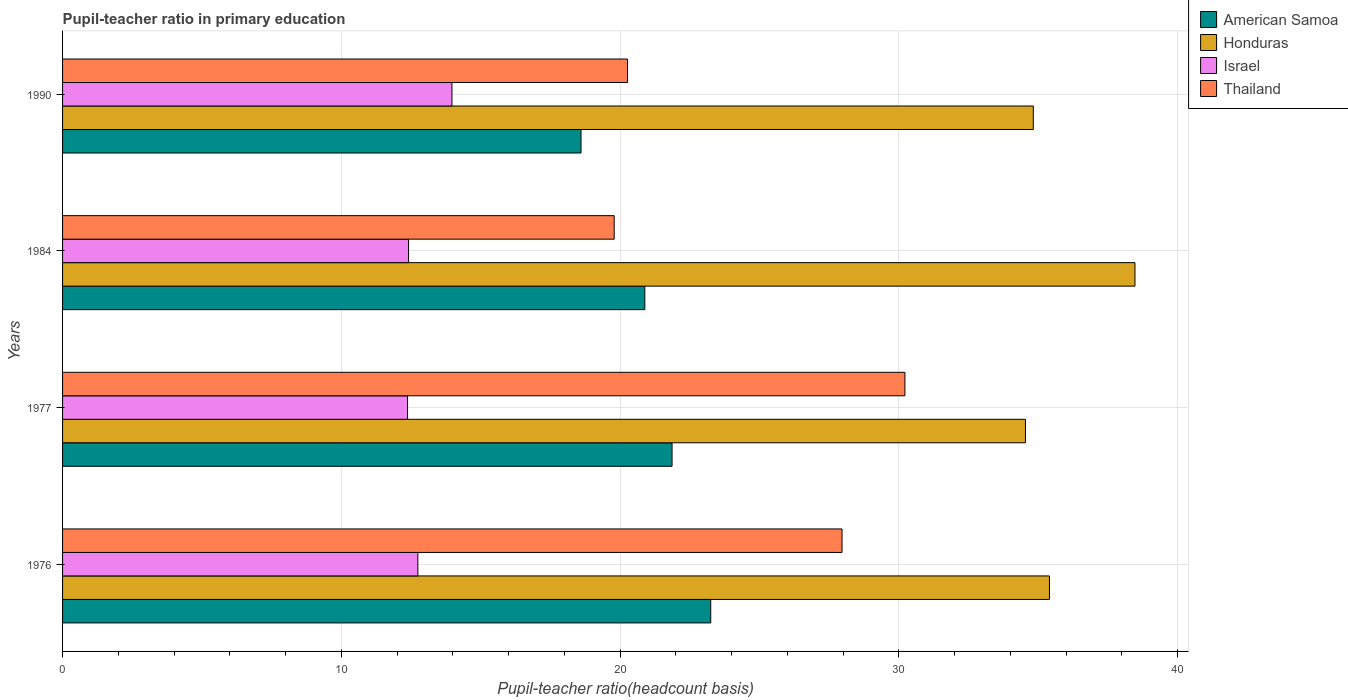How many groups of bars are there?
Make the answer very short. 4. Are the number of bars on each tick of the Y-axis equal?
Offer a terse response. Yes. How many bars are there on the 4th tick from the top?
Offer a very short reply. 4. What is the pupil-teacher ratio in primary education in Honduras in 1977?
Offer a terse response. 34.54. Across all years, what is the maximum pupil-teacher ratio in primary education in Thailand?
Make the answer very short. 30.22. Across all years, what is the minimum pupil-teacher ratio in primary education in Thailand?
Your response must be concise. 19.79. In which year was the pupil-teacher ratio in primary education in Israel maximum?
Ensure brevity in your answer.  1990. In which year was the pupil-teacher ratio in primary education in American Samoa minimum?
Make the answer very short. 1990. What is the total pupil-teacher ratio in primary education in Thailand in the graph?
Offer a very short reply. 98.24. What is the difference between the pupil-teacher ratio in primary education in American Samoa in 1976 and that in 1977?
Your answer should be very brief. 1.39. What is the difference between the pupil-teacher ratio in primary education in Honduras in 1984 and the pupil-teacher ratio in primary education in Thailand in 1976?
Offer a terse response. 10.51. What is the average pupil-teacher ratio in primary education in Honduras per year?
Offer a very short reply. 35.81. In the year 1976, what is the difference between the pupil-teacher ratio in primary education in Israel and pupil-teacher ratio in primary education in Honduras?
Ensure brevity in your answer.  -22.66. What is the ratio of the pupil-teacher ratio in primary education in Honduras in 1976 to that in 1977?
Ensure brevity in your answer.  1.02. Is the difference between the pupil-teacher ratio in primary education in Israel in 1976 and 1984 greater than the difference between the pupil-teacher ratio in primary education in Honduras in 1976 and 1984?
Provide a short and direct response. Yes. What is the difference between the highest and the second highest pupil-teacher ratio in primary education in Israel?
Offer a very short reply. 1.22. What is the difference between the highest and the lowest pupil-teacher ratio in primary education in Honduras?
Your answer should be compact. 3.93. Is the sum of the pupil-teacher ratio in primary education in Honduras in 1976 and 1990 greater than the maximum pupil-teacher ratio in primary education in Israel across all years?
Provide a succinct answer. Yes. Is it the case that in every year, the sum of the pupil-teacher ratio in primary education in Israel and pupil-teacher ratio in primary education in Thailand is greater than the sum of pupil-teacher ratio in primary education in American Samoa and pupil-teacher ratio in primary education in Honduras?
Offer a terse response. No. What does the 2nd bar from the bottom in 1984 represents?
Offer a very short reply. Honduras. Is it the case that in every year, the sum of the pupil-teacher ratio in primary education in Israel and pupil-teacher ratio in primary education in Thailand is greater than the pupil-teacher ratio in primary education in Honduras?
Offer a terse response. No. Are all the bars in the graph horizontal?
Give a very brief answer. Yes. How many years are there in the graph?
Offer a very short reply. 4. What is the difference between two consecutive major ticks on the X-axis?
Offer a terse response. 10. Does the graph contain any zero values?
Give a very brief answer. No. Does the graph contain grids?
Give a very brief answer. Yes. How many legend labels are there?
Make the answer very short. 4. How are the legend labels stacked?
Your response must be concise. Vertical. What is the title of the graph?
Your response must be concise. Pupil-teacher ratio in primary education. What is the label or title of the X-axis?
Offer a very short reply. Pupil-teacher ratio(headcount basis). What is the label or title of the Y-axis?
Provide a short and direct response. Years. What is the Pupil-teacher ratio(headcount basis) of American Samoa in 1976?
Your answer should be very brief. 23.25. What is the Pupil-teacher ratio(headcount basis) in Honduras in 1976?
Offer a terse response. 35.4. What is the Pupil-teacher ratio(headcount basis) of Israel in 1976?
Offer a very short reply. 12.74. What is the Pupil-teacher ratio(headcount basis) of Thailand in 1976?
Make the answer very short. 27.96. What is the Pupil-teacher ratio(headcount basis) in American Samoa in 1977?
Your answer should be compact. 21.86. What is the Pupil-teacher ratio(headcount basis) of Honduras in 1977?
Give a very brief answer. 34.54. What is the Pupil-teacher ratio(headcount basis) of Israel in 1977?
Offer a very short reply. 12.38. What is the Pupil-teacher ratio(headcount basis) in Thailand in 1977?
Give a very brief answer. 30.22. What is the Pupil-teacher ratio(headcount basis) of American Samoa in 1984?
Your answer should be very brief. 20.89. What is the Pupil-teacher ratio(headcount basis) of Honduras in 1984?
Provide a succinct answer. 38.47. What is the Pupil-teacher ratio(headcount basis) of Israel in 1984?
Your response must be concise. 12.41. What is the Pupil-teacher ratio(headcount basis) of Thailand in 1984?
Keep it short and to the point. 19.79. What is the Pupil-teacher ratio(headcount basis) of American Samoa in 1990?
Your answer should be very brief. 18.6. What is the Pupil-teacher ratio(headcount basis) in Honduras in 1990?
Offer a terse response. 34.82. What is the Pupil-teacher ratio(headcount basis) of Israel in 1990?
Make the answer very short. 13.97. What is the Pupil-teacher ratio(headcount basis) of Thailand in 1990?
Your answer should be compact. 20.27. Across all years, what is the maximum Pupil-teacher ratio(headcount basis) of American Samoa?
Provide a succinct answer. 23.25. Across all years, what is the maximum Pupil-teacher ratio(headcount basis) in Honduras?
Offer a very short reply. 38.47. Across all years, what is the maximum Pupil-teacher ratio(headcount basis) in Israel?
Offer a terse response. 13.97. Across all years, what is the maximum Pupil-teacher ratio(headcount basis) in Thailand?
Make the answer very short. 30.22. Across all years, what is the minimum Pupil-teacher ratio(headcount basis) in American Samoa?
Give a very brief answer. 18.6. Across all years, what is the minimum Pupil-teacher ratio(headcount basis) of Honduras?
Make the answer very short. 34.54. Across all years, what is the minimum Pupil-teacher ratio(headcount basis) of Israel?
Offer a very short reply. 12.38. Across all years, what is the minimum Pupil-teacher ratio(headcount basis) of Thailand?
Provide a short and direct response. 19.79. What is the total Pupil-teacher ratio(headcount basis) of American Samoa in the graph?
Offer a very short reply. 84.6. What is the total Pupil-teacher ratio(headcount basis) in Honduras in the graph?
Make the answer very short. 143.24. What is the total Pupil-teacher ratio(headcount basis) of Israel in the graph?
Your answer should be very brief. 51.5. What is the total Pupil-teacher ratio(headcount basis) in Thailand in the graph?
Keep it short and to the point. 98.24. What is the difference between the Pupil-teacher ratio(headcount basis) in American Samoa in 1976 and that in 1977?
Provide a short and direct response. 1.39. What is the difference between the Pupil-teacher ratio(headcount basis) of Honduras in 1976 and that in 1977?
Give a very brief answer. 0.86. What is the difference between the Pupil-teacher ratio(headcount basis) of Israel in 1976 and that in 1977?
Your response must be concise. 0.37. What is the difference between the Pupil-teacher ratio(headcount basis) of Thailand in 1976 and that in 1977?
Offer a very short reply. -2.26. What is the difference between the Pupil-teacher ratio(headcount basis) in American Samoa in 1976 and that in 1984?
Give a very brief answer. 2.36. What is the difference between the Pupil-teacher ratio(headcount basis) of Honduras in 1976 and that in 1984?
Your answer should be very brief. -3.07. What is the difference between the Pupil-teacher ratio(headcount basis) in Israel in 1976 and that in 1984?
Your answer should be very brief. 0.33. What is the difference between the Pupil-teacher ratio(headcount basis) of Thailand in 1976 and that in 1984?
Provide a short and direct response. 8.17. What is the difference between the Pupil-teacher ratio(headcount basis) in American Samoa in 1976 and that in 1990?
Provide a succinct answer. 4.65. What is the difference between the Pupil-teacher ratio(headcount basis) in Honduras in 1976 and that in 1990?
Offer a very short reply. 0.58. What is the difference between the Pupil-teacher ratio(headcount basis) in Israel in 1976 and that in 1990?
Your response must be concise. -1.22. What is the difference between the Pupil-teacher ratio(headcount basis) of Thailand in 1976 and that in 1990?
Give a very brief answer. 7.7. What is the difference between the Pupil-teacher ratio(headcount basis) of American Samoa in 1977 and that in 1984?
Your response must be concise. 0.98. What is the difference between the Pupil-teacher ratio(headcount basis) of Honduras in 1977 and that in 1984?
Give a very brief answer. -3.93. What is the difference between the Pupil-teacher ratio(headcount basis) in Israel in 1977 and that in 1984?
Provide a succinct answer. -0.04. What is the difference between the Pupil-teacher ratio(headcount basis) in Thailand in 1977 and that in 1984?
Offer a very short reply. 10.43. What is the difference between the Pupil-teacher ratio(headcount basis) in American Samoa in 1977 and that in 1990?
Your response must be concise. 3.27. What is the difference between the Pupil-teacher ratio(headcount basis) in Honduras in 1977 and that in 1990?
Offer a terse response. -0.28. What is the difference between the Pupil-teacher ratio(headcount basis) of Israel in 1977 and that in 1990?
Offer a very short reply. -1.59. What is the difference between the Pupil-teacher ratio(headcount basis) of Thailand in 1977 and that in 1990?
Offer a terse response. 9.95. What is the difference between the Pupil-teacher ratio(headcount basis) of American Samoa in 1984 and that in 1990?
Your response must be concise. 2.29. What is the difference between the Pupil-teacher ratio(headcount basis) in Honduras in 1984 and that in 1990?
Offer a terse response. 3.65. What is the difference between the Pupil-teacher ratio(headcount basis) of Israel in 1984 and that in 1990?
Your response must be concise. -1.56. What is the difference between the Pupil-teacher ratio(headcount basis) of Thailand in 1984 and that in 1990?
Provide a succinct answer. -0.48. What is the difference between the Pupil-teacher ratio(headcount basis) in American Samoa in 1976 and the Pupil-teacher ratio(headcount basis) in Honduras in 1977?
Give a very brief answer. -11.29. What is the difference between the Pupil-teacher ratio(headcount basis) in American Samoa in 1976 and the Pupil-teacher ratio(headcount basis) in Israel in 1977?
Offer a terse response. 10.88. What is the difference between the Pupil-teacher ratio(headcount basis) of American Samoa in 1976 and the Pupil-teacher ratio(headcount basis) of Thailand in 1977?
Provide a succinct answer. -6.97. What is the difference between the Pupil-teacher ratio(headcount basis) of Honduras in 1976 and the Pupil-teacher ratio(headcount basis) of Israel in 1977?
Provide a succinct answer. 23.03. What is the difference between the Pupil-teacher ratio(headcount basis) in Honduras in 1976 and the Pupil-teacher ratio(headcount basis) in Thailand in 1977?
Your answer should be compact. 5.18. What is the difference between the Pupil-teacher ratio(headcount basis) in Israel in 1976 and the Pupil-teacher ratio(headcount basis) in Thailand in 1977?
Offer a terse response. -17.47. What is the difference between the Pupil-teacher ratio(headcount basis) of American Samoa in 1976 and the Pupil-teacher ratio(headcount basis) of Honduras in 1984?
Offer a very short reply. -15.22. What is the difference between the Pupil-teacher ratio(headcount basis) of American Samoa in 1976 and the Pupil-teacher ratio(headcount basis) of Israel in 1984?
Provide a succinct answer. 10.84. What is the difference between the Pupil-teacher ratio(headcount basis) of American Samoa in 1976 and the Pupil-teacher ratio(headcount basis) of Thailand in 1984?
Give a very brief answer. 3.46. What is the difference between the Pupil-teacher ratio(headcount basis) of Honduras in 1976 and the Pupil-teacher ratio(headcount basis) of Israel in 1984?
Give a very brief answer. 22.99. What is the difference between the Pupil-teacher ratio(headcount basis) in Honduras in 1976 and the Pupil-teacher ratio(headcount basis) in Thailand in 1984?
Offer a very short reply. 15.61. What is the difference between the Pupil-teacher ratio(headcount basis) in Israel in 1976 and the Pupil-teacher ratio(headcount basis) in Thailand in 1984?
Keep it short and to the point. -7.04. What is the difference between the Pupil-teacher ratio(headcount basis) in American Samoa in 1976 and the Pupil-teacher ratio(headcount basis) in Honduras in 1990?
Your answer should be very brief. -11.57. What is the difference between the Pupil-teacher ratio(headcount basis) in American Samoa in 1976 and the Pupil-teacher ratio(headcount basis) in Israel in 1990?
Ensure brevity in your answer.  9.28. What is the difference between the Pupil-teacher ratio(headcount basis) of American Samoa in 1976 and the Pupil-teacher ratio(headcount basis) of Thailand in 1990?
Make the answer very short. 2.99. What is the difference between the Pupil-teacher ratio(headcount basis) of Honduras in 1976 and the Pupil-teacher ratio(headcount basis) of Israel in 1990?
Provide a short and direct response. 21.43. What is the difference between the Pupil-teacher ratio(headcount basis) of Honduras in 1976 and the Pupil-teacher ratio(headcount basis) of Thailand in 1990?
Provide a succinct answer. 15.14. What is the difference between the Pupil-teacher ratio(headcount basis) of Israel in 1976 and the Pupil-teacher ratio(headcount basis) of Thailand in 1990?
Provide a short and direct response. -7.52. What is the difference between the Pupil-teacher ratio(headcount basis) in American Samoa in 1977 and the Pupil-teacher ratio(headcount basis) in Honduras in 1984?
Make the answer very short. -16.61. What is the difference between the Pupil-teacher ratio(headcount basis) of American Samoa in 1977 and the Pupil-teacher ratio(headcount basis) of Israel in 1984?
Provide a succinct answer. 9.45. What is the difference between the Pupil-teacher ratio(headcount basis) of American Samoa in 1977 and the Pupil-teacher ratio(headcount basis) of Thailand in 1984?
Your answer should be very brief. 2.08. What is the difference between the Pupil-teacher ratio(headcount basis) in Honduras in 1977 and the Pupil-teacher ratio(headcount basis) in Israel in 1984?
Give a very brief answer. 22.13. What is the difference between the Pupil-teacher ratio(headcount basis) of Honduras in 1977 and the Pupil-teacher ratio(headcount basis) of Thailand in 1984?
Offer a terse response. 14.75. What is the difference between the Pupil-teacher ratio(headcount basis) of Israel in 1977 and the Pupil-teacher ratio(headcount basis) of Thailand in 1984?
Your response must be concise. -7.41. What is the difference between the Pupil-teacher ratio(headcount basis) in American Samoa in 1977 and the Pupil-teacher ratio(headcount basis) in Honduras in 1990?
Make the answer very short. -12.96. What is the difference between the Pupil-teacher ratio(headcount basis) in American Samoa in 1977 and the Pupil-teacher ratio(headcount basis) in Israel in 1990?
Keep it short and to the point. 7.9. What is the difference between the Pupil-teacher ratio(headcount basis) in American Samoa in 1977 and the Pupil-teacher ratio(headcount basis) in Thailand in 1990?
Provide a succinct answer. 1.6. What is the difference between the Pupil-teacher ratio(headcount basis) in Honduras in 1977 and the Pupil-teacher ratio(headcount basis) in Israel in 1990?
Make the answer very short. 20.57. What is the difference between the Pupil-teacher ratio(headcount basis) in Honduras in 1977 and the Pupil-teacher ratio(headcount basis) in Thailand in 1990?
Make the answer very short. 14.28. What is the difference between the Pupil-teacher ratio(headcount basis) in Israel in 1977 and the Pupil-teacher ratio(headcount basis) in Thailand in 1990?
Provide a succinct answer. -7.89. What is the difference between the Pupil-teacher ratio(headcount basis) in American Samoa in 1984 and the Pupil-teacher ratio(headcount basis) in Honduras in 1990?
Your response must be concise. -13.94. What is the difference between the Pupil-teacher ratio(headcount basis) of American Samoa in 1984 and the Pupil-teacher ratio(headcount basis) of Israel in 1990?
Your answer should be very brief. 6.92. What is the difference between the Pupil-teacher ratio(headcount basis) in American Samoa in 1984 and the Pupil-teacher ratio(headcount basis) in Thailand in 1990?
Offer a terse response. 0.62. What is the difference between the Pupil-teacher ratio(headcount basis) in Honduras in 1984 and the Pupil-teacher ratio(headcount basis) in Israel in 1990?
Give a very brief answer. 24.5. What is the difference between the Pupil-teacher ratio(headcount basis) of Honduras in 1984 and the Pupil-teacher ratio(headcount basis) of Thailand in 1990?
Provide a short and direct response. 18.2. What is the difference between the Pupil-teacher ratio(headcount basis) in Israel in 1984 and the Pupil-teacher ratio(headcount basis) in Thailand in 1990?
Give a very brief answer. -7.85. What is the average Pupil-teacher ratio(headcount basis) in American Samoa per year?
Your answer should be compact. 21.15. What is the average Pupil-teacher ratio(headcount basis) of Honduras per year?
Provide a short and direct response. 35.81. What is the average Pupil-teacher ratio(headcount basis) of Israel per year?
Provide a succinct answer. 12.88. What is the average Pupil-teacher ratio(headcount basis) in Thailand per year?
Ensure brevity in your answer.  24.56. In the year 1976, what is the difference between the Pupil-teacher ratio(headcount basis) in American Samoa and Pupil-teacher ratio(headcount basis) in Honduras?
Your answer should be very brief. -12.15. In the year 1976, what is the difference between the Pupil-teacher ratio(headcount basis) of American Samoa and Pupil-teacher ratio(headcount basis) of Israel?
Your response must be concise. 10.51. In the year 1976, what is the difference between the Pupil-teacher ratio(headcount basis) of American Samoa and Pupil-teacher ratio(headcount basis) of Thailand?
Keep it short and to the point. -4.71. In the year 1976, what is the difference between the Pupil-teacher ratio(headcount basis) of Honduras and Pupil-teacher ratio(headcount basis) of Israel?
Make the answer very short. 22.66. In the year 1976, what is the difference between the Pupil-teacher ratio(headcount basis) in Honduras and Pupil-teacher ratio(headcount basis) in Thailand?
Your answer should be very brief. 7.44. In the year 1976, what is the difference between the Pupil-teacher ratio(headcount basis) in Israel and Pupil-teacher ratio(headcount basis) in Thailand?
Provide a short and direct response. -15.22. In the year 1977, what is the difference between the Pupil-teacher ratio(headcount basis) of American Samoa and Pupil-teacher ratio(headcount basis) of Honduras?
Offer a terse response. -12.68. In the year 1977, what is the difference between the Pupil-teacher ratio(headcount basis) of American Samoa and Pupil-teacher ratio(headcount basis) of Israel?
Keep it short and to the point. 9.49. In the year 1977, what is the difference between the Pupil-teacher ratio(headcount basis) in American Samoa and Pupil-teacher ratio(headcount basis) in Thailand?
Provide a succinct answer. -8.35. In the year 1977, what is the difference between the Pupil-teacher ratio(headcount basis) in Honduras and Pupil-teacher ratio(headcount basis) in Israel?
Provide a short and direct response. 22.17. In the year 1977, what is the difference between the Pupil-teacher ratio(headcount basis) in Honduras and Pupil-teacher ratio(headcount basis) in Thailand?
Make the answer very short. 4.32. In the year 1977, what is the difference between the Pupil-teacher ratio(headcount basis) in Israel and Pupil-teacher ratio(headcount basis) in Thailand?
Offer a very short reply. -17.84. In the year 1984, what is the difference between the Pupil-teacher ratio(headcount basis) of American Samoa and Pupil-teacher ratio(headcount basis) of Honduras?
Your response must be concise. -17.58. In the year 1984, what is the difference between the Pupil-teacher ratio(headcount basis) in American Samoa and Pupil-teacher ratio(headcount basis) in Israel?
Offer a very short reply. 8.47. In the year 1984, what is the difference between the Pupil-teacher ratio(headcount basis) in American Samoa and Pupil-teacher ratio(headcount basis) in Thailand?
Ensure brevity in your answer.  1.1. In the year 1984, what is the difference between the Pupil-teacher ratio(headcount basis) in Honduras and Pupil-teacher ratio(headcount basis) in Israel?
Offer a very short reply. 26.06. In the year 1984, what is the difference between the Pupil-teacher ratio(headcount basis) of Honduras and Pupil-teacher ratio(headcount basis) of Thailand?
Ensure brevity in your answer.  18.68. In the year 1984, what is the difference between the Pupil-teacher ratio(headcount basis) of Israel and Pupil-teacher ratio(headcount basis) of Thailand?
Provide a short and direct response. -7.38. In the year 1990, what is the difference between the Pupil-teacher ratio(headcount basis) of American Samoa and Pupil-teacher ratio(headcount basis) of Honduras?
Your answer should be compact. -16.22. In the year 1990, what is the difference between the Pupil-teacher ratio(headcount basis) in American Samoa and Pupil-teacher ratio(headcount basis) in Israel?
Your response must be concise. 4.63. In the year 1990, what is the difference between the Pupil-teacher ratio(headcount basis) in American Samoa and Pupil-teacher ratio(headcount basis) in Thailand?
Make the answer very short. -1.67. In the year 1990, what is the difference between the Pupil-teacher ratio(headcount basis) of Honduras and Pupil-teacher ratio(headcount basis) of Israel?
Give a very brief answer. 20.85. In the year 1990, what is the difference between the Pupil-teacher ratio(headcount basis) of Honduras and Pupil-teacher ratio(headcount basis) of Thailand?
Make the answer very short. 14.56. In the year 1990, what is the difference between the Pupil-teacher ratio(headcount basis) in Israel and Pupil-teacher ratio(headcount basis) in Thailand?
Give a very brief answer. -6.3. What is the ratio of the Pupil-teacher ratio(headcount basis) of American Samoa in 1976 to that in 1977?
Give a very brief answer. 1.06. What is the ratio of the Pupil-teacher ratio(headcount basis) of Honduras in 1976 to that in 1977?
Offer a very short reply. 1.02. What is the ratio of the Pupil-teacher ratio(headcount basis) in Israel in 1976 to that in 1977?
Your answer should be very brief. 1.03. What is the ratio of the Pupil-teacher ratio(headcount basis) of Thailand in 1976 to that in 1977?
Ensure brevity in your answer.  0.93. What is the ratio of the Pupil-teacher ratio(headcount basis) of American Samoa in 1976 to that in 1984?
Your response must be concise. 1.11. What is the ratio of the Pupil-teacher ratio(headcount basis) of Honduras in 1976 to that in 1984?
Ensure brevity in your answer.  0.92. What is the ratio of the Pupil-teacher ratio(headcount basis) in Israel in 1976 to that in 1984?
Ensure brevity in your answer.  1.03. What is the ratio of the Pupil-teacher ratio(headcount basis) in Thailand in 1976 to that in 1984?
Make the answer very short. 1.41. What is the ratio of the Pupil-teacher ratio(headcount basis) in American Samoa in 1976 to that in 1990?
Your answer should be compact. 1.25. What is the ratio of the Pupil-teacher ratio(headcount basis) in Honduras in 1976 to that in 1990?
Ensure brevity in your answer.  1.02. What is the ratio of the Pupil-teacher ratio(headcount basis) of Israel in 1976 to that in 1990?
Offer a terse response. 0.91. What is the ratio of the Pupil-teacher ratio(headcount basis) of Thailand in 1976 to that in 1990?
Offer a very short reply. 1.38. What is the ratio of the Pupil-teacher ratio(headcount basis) of American Samoa in 1977 to that in 1984?
Your answer should be compact. 1.05. What is the ratio of the Pupil-teacher ratio(headcount basis) of Honduras in 1977 to that in 1984?
Ensure brevity in your answer.  0.9. What is the ratio of the Pupil-teacher ratio(headcount basis) in Israel in 1977 to that in 1984?
Provide a short and direct response. 1. What is the ratio of the Pupil-teacher ratio(headcount basis) in Thailand in 1977 to that in 1984?
Make the answer very short. 1.53. What is the ratio of the Pupil-teacher ratio(headcount basis) in American Samoa in 1977 to that in 1990?
Provide a succinct answer. 1.18. What is the ratio of the Pupil-teacher ratio(headcount basis) in Honduras in 1977 to that in 1990?
Offer a terse response. 0.99. What is the ratio of the Pupil-teacher ratio(headcount basis) of Israel in 1977 to that in 1990?
Your answer should be compact. 0.89. What is the ratio of the Pupil-teacher ratio(headcount basis) of Thailand in 1977 to that in 1990?
Your answer should be compact. 1.49. What is the ratio of the Pupil-teacher ratio(headcount basis) in American Samoa in 1984 to that in 1990?
Ensure brevity in your answer.  1.12. What is the ratio of the Pupil-teacher ratio(headcount basis) in Honduras in 1984 to that in 1990?
Provide a short and direct response. 1.1. What is the ratio of the Pupil-teacher ratio(headcount basis) in Israel in 1984 to that in 1990?
Your answer should be very brief. 0.89. What is the ratio of the Pupil-teacher ratio(headcount basis) in Thailand in 1984 to that in 1990?
Keep it short and to the point. 0.98. What is the difference between the highest and the second highest Pupil-teacher ratio(headcount basis) of American Samoa?
Make the answer very short. 1.39. What is the difference between the highest and the second highest Pupil-teacher ratio(headcount basis) in Honduras?
Offer a terse response. 3.07. What is the difference between the highest and the second highest Pupil-teacher ratio(headcount basis) in Israel?
Make the answer very short. 1.22. What is the difference between the highest and the second highest Pupil-teacher ratio(headcount basis) in Thailand?
Make the answer very short. 2.26. What is the difference between the highest and the lowest Pupil-teacher ratio(headcount basis) in American Samoa?
Your response must be concise. 4.65. What is the difference between the highest and the lowest Pupil-teacher ratio(headcount basis) of Honduras?
Ensure brevity in your answer.  3.93. What is the difference between the highest and the lowest Pupil-teacher ratio(headcount basis) in Israel?
Your answer should be compact. 1.59. What is the difference between the highest and the lowest Pupil-teacher ratio(headcount basis) of Thailand?
Make the answer very short. 10.43. 